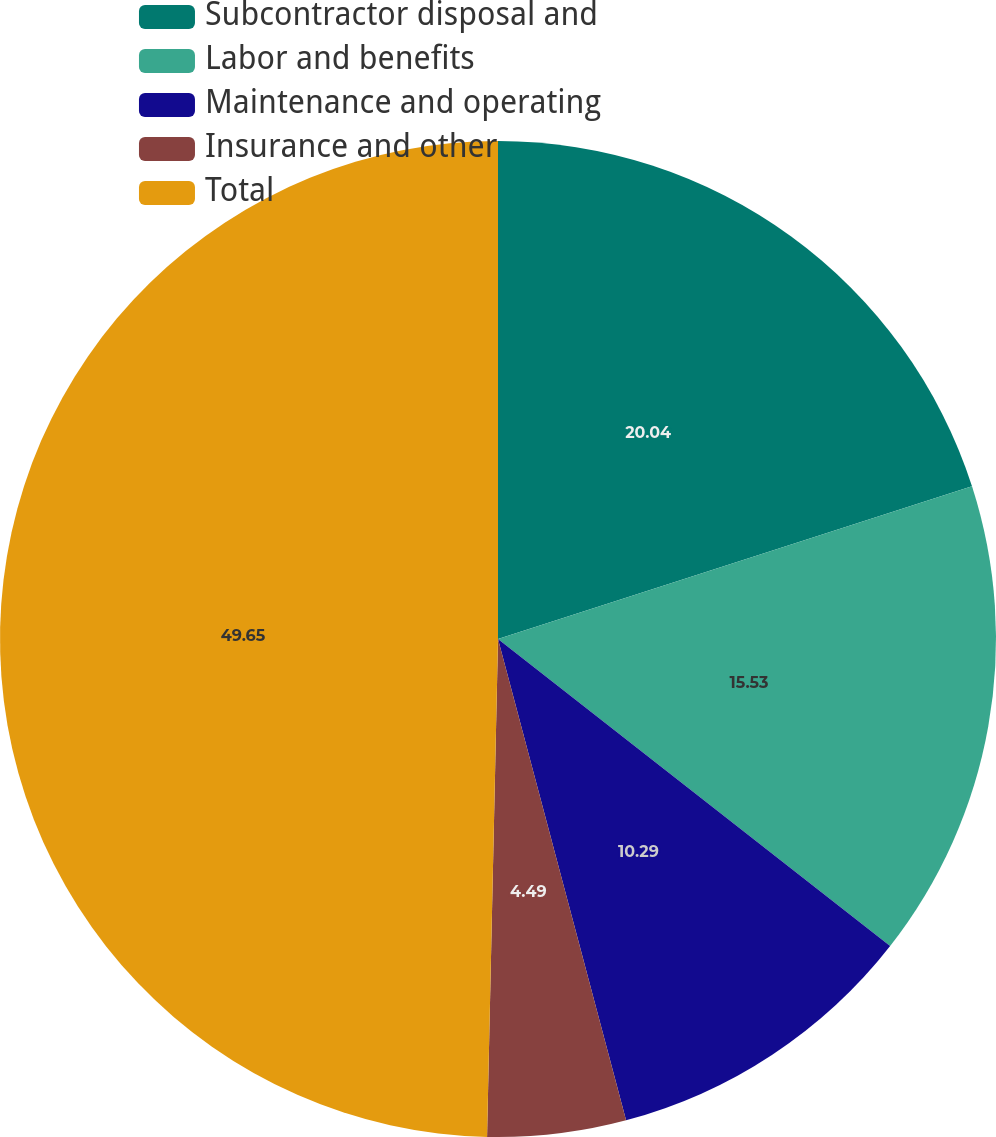Convert chart. <chart><loc_0><loc_0><loc_500><loc_500><pie_chart><fcel>Subcontractor disposal and<fcel>Labor and benefits<fcel>Maintenance and operating<fcel>Insurance and other<fcel>Total<nl><fcel>20.04%<fcel>15.53%<fcel>10.29%<fcel>4.49%<fcel>49.65%<nl></chart> 